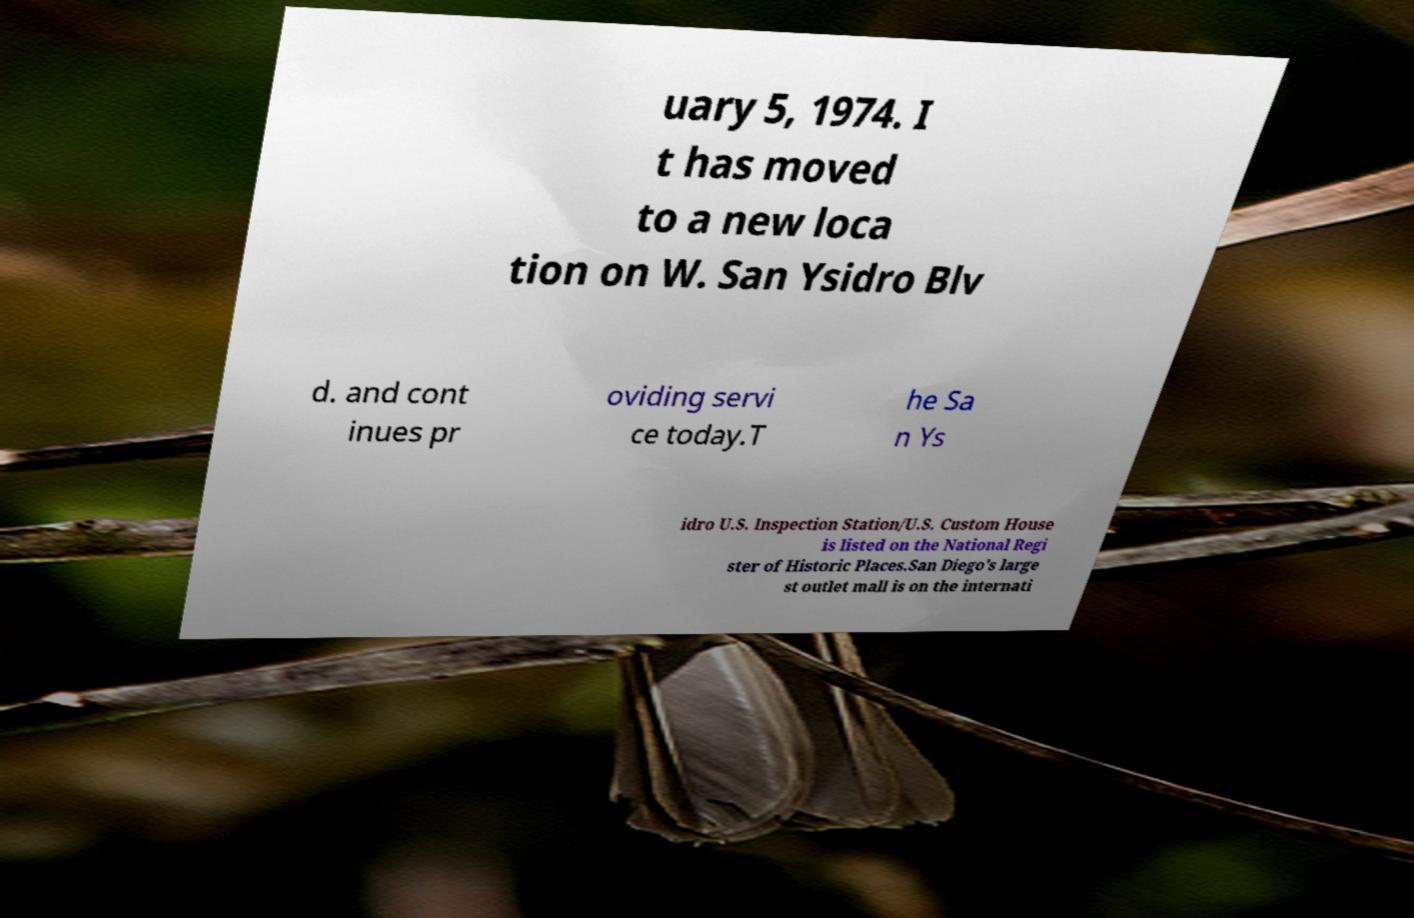For documentation purposes, I need the text within this image transcribed. Could you provide that? uary 5, 1974. I t has moved to a new loca tion on W. San Ysidro Blv d. and cont inues pr oviding servi ce today.T he Sa n Ys idro U.S. Inspection Station/U.S. Custom House is listed on the National Regi ster of Historic Places.San Diego's large st outlet mall is on the internati 